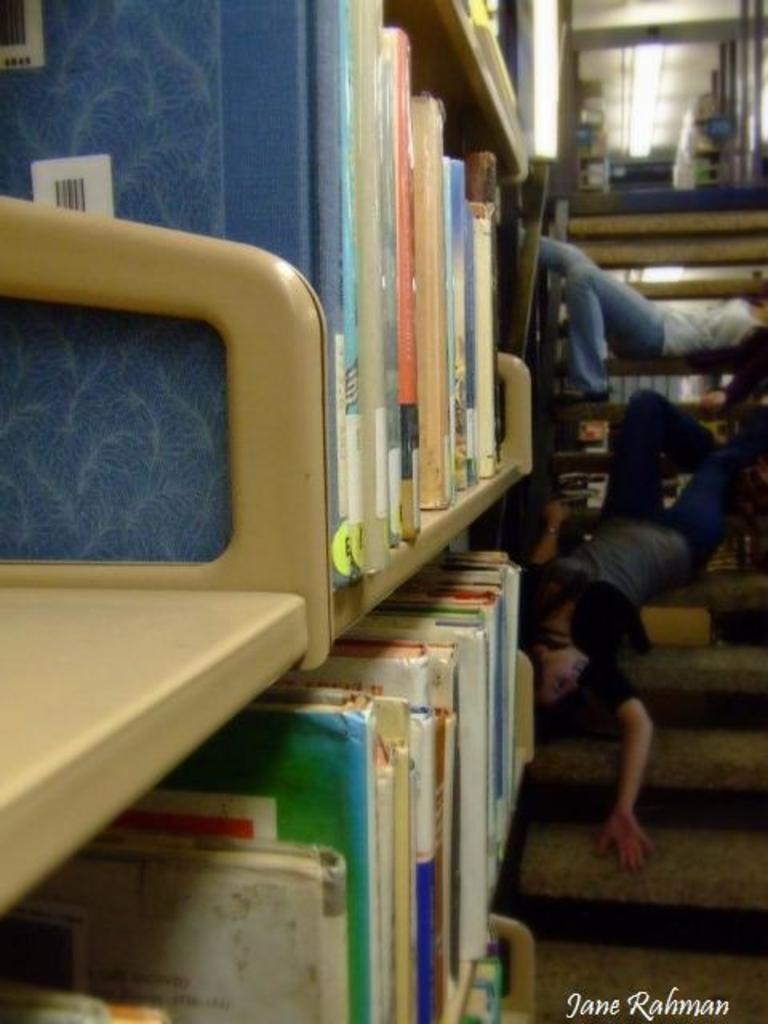What are the people in the image doing? The people in the image are on the stairs. What can be seen on the left side of the image? There are shelves on the left side of the image. What is placed on the shelves? Books are placed on the shelves. Can you tell me how many chances the leaf on the stairs has to win the race? There is no leaf or race present in the image; it features people on the stairs and shelves with books. 